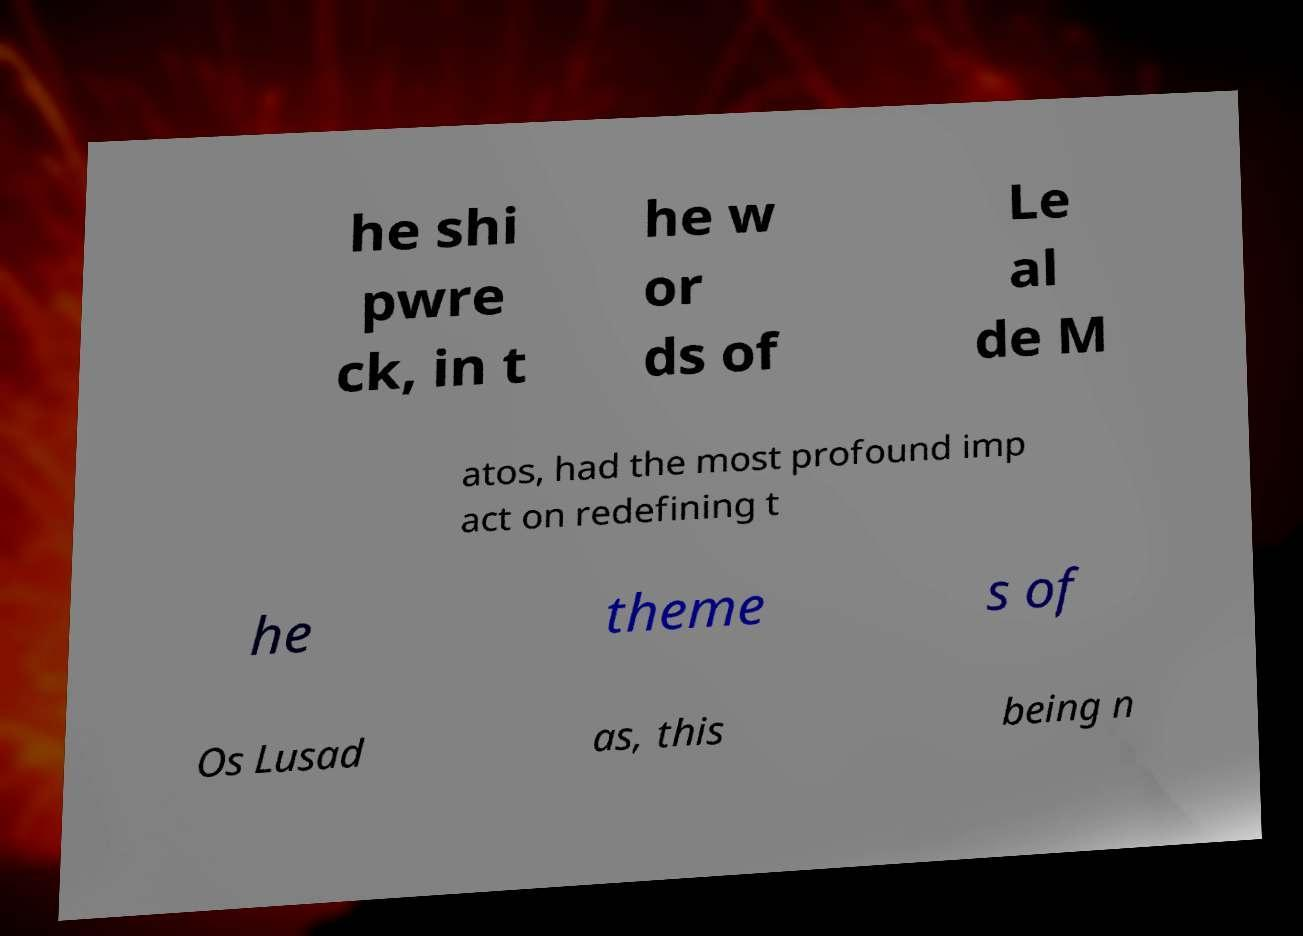What messages or text are displayed in this image? I need them in a readable, typed format. he shi pwre ck, in t he w or ds of Le al de M atos, had the most profound imp act on redefining t he theme s of Os Lusad as, this being n 